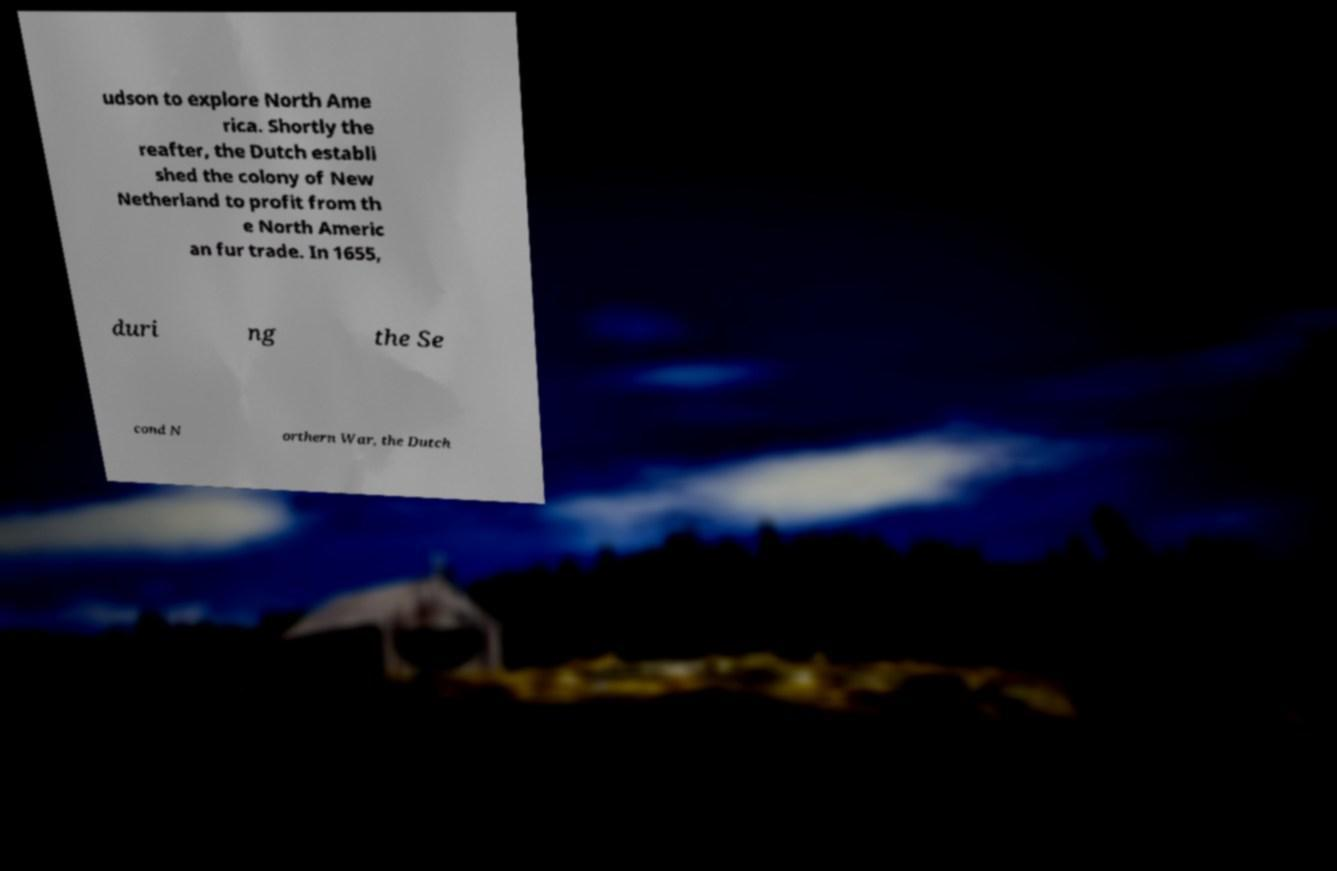Could you extract and type out the text from this image? udson to explore North Ame rica. Shortly the reafter, the Dutch establi shed the colony of New Netherland to profit from th e North Americ an fur trade. In 1655, duri ng the Se cond N orthern War, the Dutch 